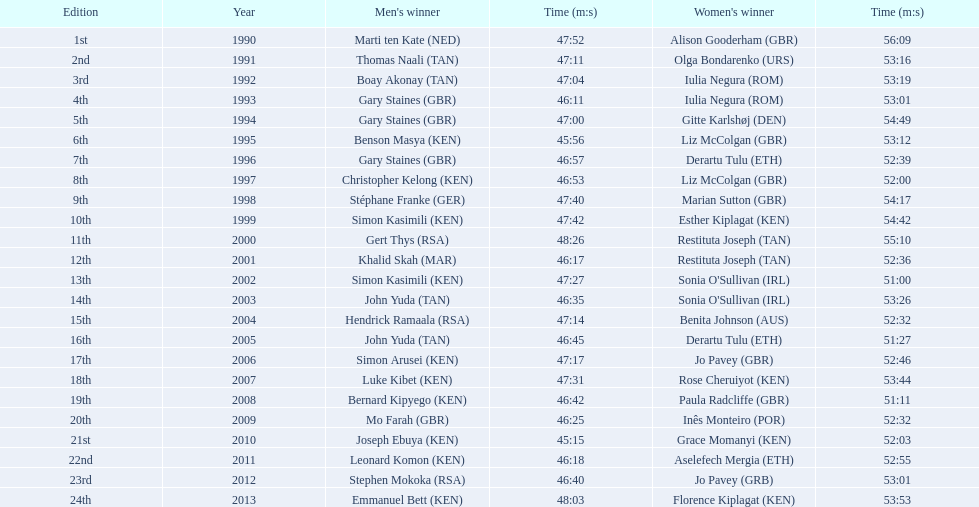What years were the races held? 1990, 1991, 1992, 1993, 1994, 1995, 1996, 1997, 1998, 1999, 2000, 2001, 2002, 2003, 2004, 2005, 2006, 2007, 2008, 2009, 2010, 2011, 2012, 2013. Would you mind parsing the complete table? {'header': ['Edition', 'Year', "Men's winner", 'Time (m:s)', "Women's winner", 'Time (m:s)'], 'rows': [['1st', '1990', 'Marti ten Kate\xa0(NED)', '47:52', 'Alison Gooderham\xa0(GBR)', '56:09'], ['2nd', '1991', 'Thomas Naali\xa0(TAN)', '47:11', 'Olga Bondarenko\xa0(URS)', '53:16'], ['3rd', '1992', 'Boay Akonay\xa0(TAN)', '47:04', 'Iulia Negura\xa0(ROM)', '53:19'], ['4th', '1993', 'Gary Staines\xa0(GBR)', '46:11', 'Iulia Negura\xa0(ROM)', '53:01'], ['5th', '1994', 'Gary Staines\xa0(GBR)', '47:00', 'Gitte Karlshøj\xa0(DEN)', '54:49'], ['6th', '1995', 'Benson Masya\xa0(KEN)', '45:56', 'Liz McColgan\xa0(GBR)', '53:12'], ['7th', '1996', 'Gary Staines\xa0(GBR)', '46:57', 'Derartu Tulu\xa0(ETH)', '52:39'], ['8th', '1997', 'Christopher Kelong\xa0(KEN)', '46:53', 'Liz McColgan\xa0(GBR)', '52:00'], ['9th', '1998', 'Stéphane Franke\xa0(GER)', '47:40', 'Marian Sutton\xa0(GBR)', '54:17'], ['10th', '1999', 'Simon Kasimili\xa0(KEN)', '47:42', 'Esther Kiplagat\xa0(KEN)', '54:42'], ['11th', '2000', 'Gert Thys\xa0(RSA)', '48:26', 'Restituta Joseph\xa0(TAN)', '55:10'], ['12th', '2001', 'Khalid Skah\xa0(MAR)', '46:17', 'Restituta Joseph\xa0(TAN)', '52:36'], ['13th', '2002', 'Simon Kasimili\xa0(KEN)', '47:27', "Sonia O'Sullivan\xa0(IRL)", '51:00'], ['14th', '2003', 'John Yuda\xa0(TAN)', '46:35', "Sonia O'Sullivan\xa0(IRL)", '53:26'], ['15th', '2004', 'Hendrick Ramaala\xa0(RSA)', '47:14', 'Benita Johnson\xa0(AUS)', '52:32'], ['16th', '2005', 'John Yuda\xa0(TAN)', '46:45', 'Derartu Tulu\xa0(ETH)', '51:27'], ['17th', '2006', 'Simon Arusei\xa0(KEN)', '47:17', 'Jo Pavey\xa0(GBR)', '52:46'], ['18th', '2007', 'Luke Kibet\xa0(KEN)', '47:31', 'Rose Cheruiyot\xa0(KEN)', '53:44'], ['19th', '2008', 'Bernard Kipyego\xa0(KEN)', '46:42', 'Paula Radcliffe\xa0(GBR)', '51:11'], ['20th', '2009', 'Mo Farah\xa0(GBR)', '46:25', 'Inês Monteiro\xa0(POR)', '52:32'], ['21st', '2010', 'Joseph Ebuya\xa0(KEN)', '45:15', 'Grace Momanyi\xa0(KEN)', '52:03'], ['22nd', '2011', 'Leonard Komon\xa0(KEN)', '46:18', 'Aselefech Mergia\xa0(ETH)', '52:55'], ['23rd', '2012', 'Stephen Mokoka\xa0(RSA)', '46:40', 'Jo Pavey\xa0(GRB)', '53:01'], ['24th', '2013', 'Emmanuel Bett\xa0(KEN)', '48:03', 'Florence Kiplagat\xa0(KEN)', '53:53']]} Who was the woman's winner of the 2003 race? Sonia O'Sullivan (IRL). What was her time? 53:26. Which participants are kenyan runners? Benson Masya (KEN), Christopher Kelong (KEN), Simon Kasimili (KEN), Simon Kasimili (KEN), Simon Arusei (KEN), Luke Kibet (KEN), Bernard Kipyego (KEN), Joseph Ebuya (KEN), Leonard Komon (KEN), Emmanuel Bett (KEN). Out of these, who has completed the race in less than 46 minutes? Benson Masya (KEN), Joseph Ebuya (KEN). Which one of these runners has the best time? Joseph Ebuya (KEN). 